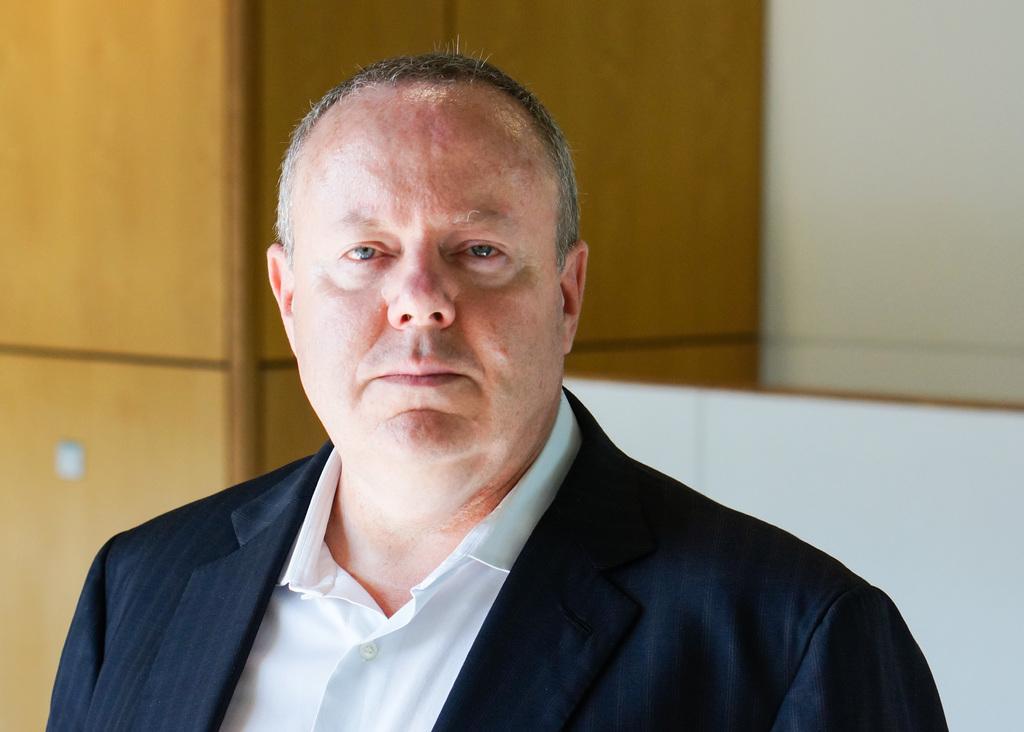Describe this image in one or two sentences. This image is taken indoors. In the background there is a wall. In the middle of the image there is a man. He has worn a suit and a shirt which is white in color. 